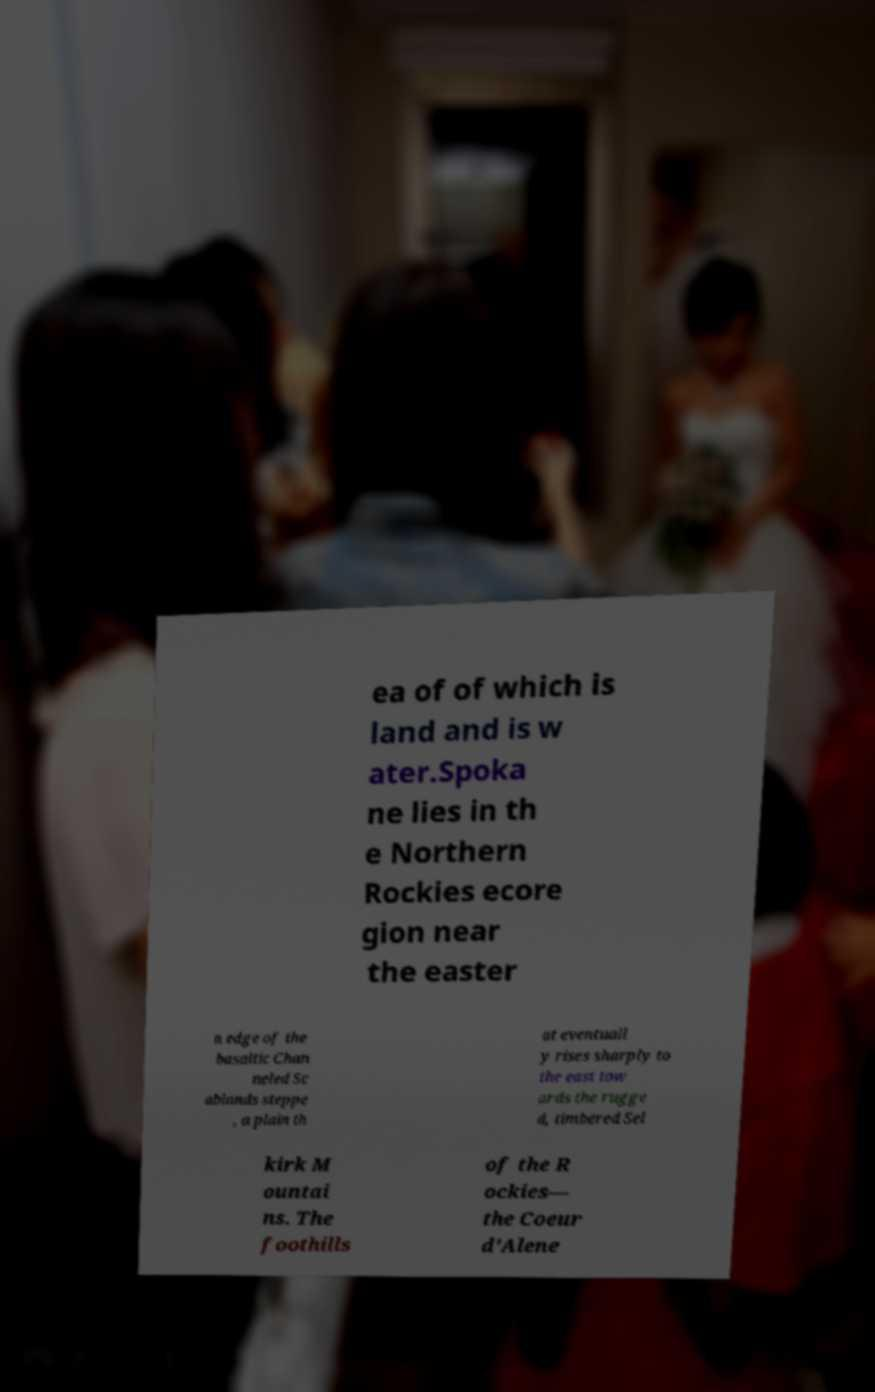Could you extract and type out the text from this image? ea of of which is land and is w ater.Spoka ne lies in th e Northern Rockies ecore gion near the easter n edge of the basaltic Chan neled Sc ablands steppe , a plain th at eventuall y rises sharply to the east tow ards the rugge d, timbered Sel kirk M ountai ns. The foothills of the R ockies— the Coeur d'Alene 